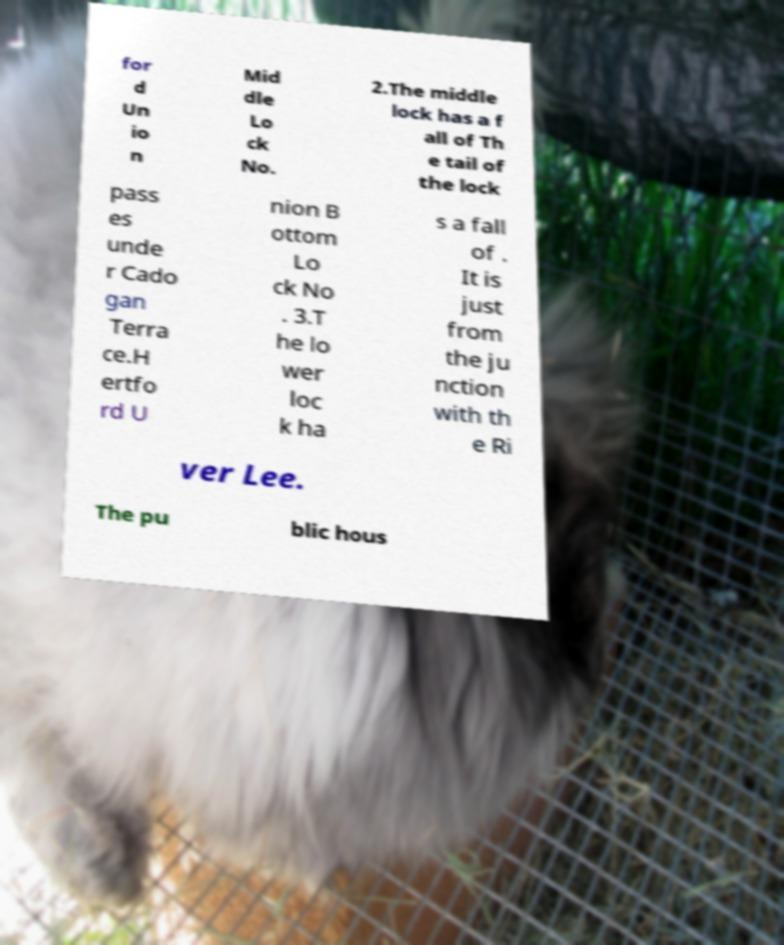What messages or text are displayed in this image? I need them in a readable, typed format. for d Un io n Mid dle Lo ck No. 2.The middle lock has a f all of Th e tail of the lock pass es unde r Cado gan Terra ce.H ertfo rd U nion B ottom Lo ck No . 3.T he lo wer loc k ha s a fall of . It is just from the ju nction with th e Ri ver Lee. The pu blic hous 